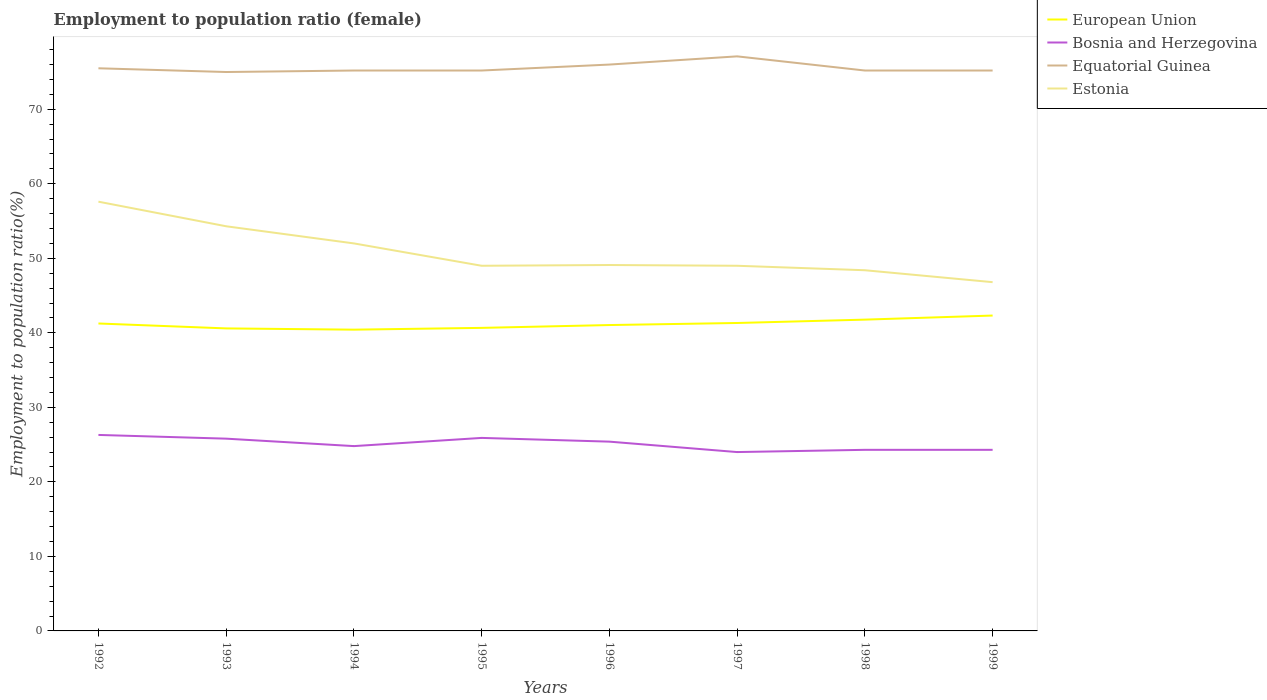Is the number of lines equal to the number of legend labels?
Offer a very short reply. Yes. What is the total employment to population ratio in Estonia in the graph?
Provide a short and direct response. 0.6. What is the difference between the highest and the second highest employment to population ratio in Bosnia and Herzegovina?
Your answer should be compact. 2.3. What is the difference between the highest and the lowest employment to population ratio in Equatorial Guinea?
Offer a very short reply. 2. Is the employment to population ratio in European Union strictly greater than the employment to population ratio in Estonia over the years?
Your answer should be very brief. Yes. How many years are there in the graph?
Your answer should be compact. 8. Are the values on the major ticks of Y-axis written in scientific E-notation?
Ensure brevity in your answer.  No. Does the graph contain grids?
Your answer should be very brief. No. What is the title of the graph?
Your answer should be compact. Employment to population ratio (female). Does "West Bank and Gaza" appear as one of the legend labels in the graph?
Ensure brevity in your answer.  No. What is the Employment to population ratio(%) in European Union in 1992?
Provide a succinct answer. 41.26. What is the Employment to population ratio(%) in Bosnia and Herzegovina in 1992?
Your answer should be very brief. 26.3. What is the Employment to population ratio(%) in Equatorial Guinea in 1992?
Make the answer very short. 75.5. What is the Employment to population ratio(%) of Estonia in 1992?
Offer a terse response. 57.6. What is the Employment to population ratio(%) in European Union in 1993?
Ensure brevity in your answer.  40.59. What is the Employment to population ratio(%) of Bosnia and Herzegovina in 1993?
Provide a short and direct response. 25.8. What is the Employment to population ratio(%) of Equatorial Guinea in 1993?
Give a very brief answer. 75. What is the Employment to population ratio(%) in Estonia in 1993?
Keep it short and to the point. 54.3. What is the Employment to population ratio(%) in European Union in 1994?
Your answer should be very brief. 40.43. What is the Employment to population ratio(%) of Bosnia and Herzegovina in 1994?
Provide a short and direct response. 24.8. What is the Employment to population ratio(%) of Equatorial Guinea in 1994?
Ensure brevity in your answer.  75.2. What is the Employment to population ratio(%) in Estonia in 1994?
Keep it short and to the point. 52. What is the Employment to population ratio(%) in European Union in 1995?
Your answer should be very brief. 40.67. What is the Employment to population ratio(%) of Bosnia and Herzegovina in 1995?
Your answer should be very brief. 25.9. What is the Employment to population ratio(%) of Equatorial Guinea in 1995?
Make the answer very short. 75.2. What is the Employment to population ratio(%) in European Union in 1996?
Ensure brevity in your answer.  41.05. What is the Employment to population ratio(%) in Bosnia and Herzegovina in 1996?
Provide a short and direct response. 25.4. What is the Employment to population ratio(%) of Equatorial Guinea in 1996?
Ensure brevity in your answer.  76. What is the Employment to population ratio(%) of Estonia in 1996?
Your response must be concise. 49.1. What is the Employment to population ratio(%) of European Union in 1997?
Provide a succinct answer. 41.32. What is the Employment to population ratio(%) of Equatorial Guinea in 1997?
Offer a very short reply. 77.1. What is the Employment to population ratio(%) of Estonia in 1997?
Provide a short and direct response. 49. What is the Employment to population ratio(%) of European Union in 1998?
Your response must be concise. 41.77. What is the Employment to population ratio(%) in Bosnia and Herzegovina in 1998?
Your answer should be very brief. 24.3. What is the Employment to population ratio(%) in Equatorial Guinea in 1998?
Ensure brevity in your answer.  75.2. What is the Employment to population ratio(%) in Estonia in 1998?
Give a very brief answer. 48.4. What is the Employment to population ratio(%) of European Union in 1999?
Give a very brief answer. 42.32. What is the Employment to population ratio(%) of Bosnia and Herzegovina in 1999?
Make the answer very short. 24.3. What is the Employment to population ratio(%) in Equatorial Guinea in 1999?
Keep it short and to the point. 75.2. What is the Employment to population ratio(%) in Estonia in 1999?
Ensure brevity in your answer.  46.8. Across all years, what is the maximum Employment to population ratio(%) in European Union?
Keep it short and to the point. 42.32. Across all years, what is the maximum Employment to population ratio(%) in Bosnia and Herzegovina?
Provide a succinct answer. 26.3. Across all years, what is the maximum Employment to population ratio(%) in Equatorial Guinea?
Offer a terse response. 77.1. Across all years, what is the maximum Employment to population ratio(%) in Estonia?
Offer a very short reply. 57.6. Across all years, what is the minimum Employment to population ratio(%) in European Union?
Provide a succinct answer. 40.43. Across all years, what is the minimum Employment to population ratio(%) of Bosnia and Herzegovina?
Offer a terse response. 24. Across all years, what is the minimum Employment to population ratio(%) in Equatorial Guinea?
Provide a succinct answer. 75. Across all years, what is the minimum Employment to population ratio(%) of Estonia?
Provide a succinct answer. 46.8. What is the total Employment to population ratio(%) in European Union in the graph?
Ensure brevity in your answer.  329.4. What is the total Employment to population ratio(%) of Bosnia and Herzegovina in the graph?
Your answer should be compact. 200.8. What is the total Employment to population ratio(%) of Equatorial Guinea in the graph?
Your response must be concise. 604.4. What is the total Employment to population ratio(%) of Estonia in the graph?
Keep it short and to the point. 406.2. What is the difference between the Employment to population ratio(%) of European Union in 1992 and that in 1993?
Offer a very short reply. 0.66. What is the difference between the Employment to population ratio(%) of Equatorial Guinea in 1992 and that in 1993?
Offer a terse response. 0.5. What is the difference between the Employment to population ratio(%) in Estonia in 1992 and that in 1993?
Provide a short and direct response. 3.3. What is the difference between the Employment to population ratio(%) in European Union in 1992 and that in 1994?
Offer a very short reply. 0.83. What is the difference between the Employment to population ratio(%) in European Union in 1992 and that in 1995?
Your response must be concise. 0.59. What is the difference between the Employment to population ratio(%) in Bosnia and Herzegovina in 1992 and that in 1995?
Your answer should be very brief. 0.4. What is the difference between the Employment to population ratio(%) in Estonia in 1992 and that in 1995?
Offer a very short reply. 8.6. What is the difference between the Employment to population ratio(%) of European Union in 1992 and that in 1996?
Offer a very short reply. 0.21. What is the difference between the Employment to population ratio(%) in Equatorial Guinea in 1992 and that in 1996?
Your answer should be very brief. -0.5. What is the difference between the Employment to population ratio(%) of European Union in 1992 and that in 1997?
Offer a very short reply. -0.07. What is the difference between the Employment to population ratio(%) of European Union in 1992 and that in 1998?
Keep it short and to the point. -0.52. What is the difference between the Employment to population ratio(%) of Estonia in 1992 and that in 1998?
Give a very brief answer. 9.2. What is the difference between the Employment to population ratio(%) in European Union in 1992 and that in 1999?
Make the answer very short. -1.06. What is the difference between the Employment to population ratio(%) in Equatorial Guinea in 1992 and that in 1999?
Ensure brevity in your answer.  0.3. What is the difference between the Employment to population ratio(%) of Estonia in 1992 and that in 1999?
Keep it short and to the point. 10.8. What is the difference between the Employment to population ratio(%) of European Union in 1993 and that in 1994?
Your answer should be compact. 0.17. What is the difference between the Employment to population ratio(%) of Bosnia and Herzegovina in 1993 and that in 1994?
Ensure brevity in your answer.  1. What is the difference between the Employment to population ratio(%) in Estonia in 1993 and that in 1994?
Your answer should be very brief. 2.3. What is the difference between the Employment to population ratio(%) of European Union in 1993 and that in 1995?
Your answer should be very brief. -0.07. What is the difference between the Employment to population ratio(%) in Bosnia and Herzegovina in 1993 and that in 1995?
Your answer should be compact. -0.1. What is the difference between the Employment to population ratio(%) in Equatorial Guinea in 1993 and that in 1995?
Offer a terse response. -0.2. What is the difference between the Employment to population ratio(%) of Estonia in 1993 and that in 1995?
Your answer should be compact. 5.3. What is the difference between the Employment to population ratio(%) of European Union in 1993 and that in 1996?
Provide a succinct answer. -0.45. What is the difference between the Employment to population ratio(%) of Bosnia and Herzegovina in 1993 and that in 1996?
Ensure brevity in your answer.  0.4. What is the difference between the Employment to population ratio(%) of European Union in 1993 and that in 1997?
Your answer should be compact. -0.73. What is the difference between the Employment to population ratio(%) in Estonia in 1993 and that in 1997?
Your answer should be compact. 5.3. What is the difference between the Employment to population ratio(%) in European Union in 1993 and that in 1998?
Your answer should be compact. -1.18. What is the difference between the Employment to population ratio(%) of Bosnia and Herzegovina in 1993 and that in 1998?
Provide a succinct answer. 1.5. What is the difference between the Employment to population ratio(%) in Equatorial Guinea in 1993 and that in 1998?
Keep it short and to the point. -0.2. What is the difference between the Employment to population ratio(%) of Estonia in 1993 and that in 1998?
Provide a short and direct response. 5.9. What is the difference between the Employment to population ratio(%) of European Union in 1993 and that in 1999?
Provide a succinct answer. -1.73. What is the difference between the Employment to population ratio(%) in Estonia in 1993 and that in 1999?
Offer a terse response. 7.5. What is the difference between the Employment to population ratio(%) of European Union in 1994 and that in 1995?
Make the answer very short. -0.24. What is the difference between the Employment to population ratio(%) in Bosnia and Herzegovina in 1994 and that in 1995?
Give a very brief answer. -1.1. What is the difference between the Employment to population ratio(%) of Equatorial Guinea in 1994 and that in 1995?
Your answer should be compact. 0. What is the difference between the Employment to population ratio(%) in European Union in 1994 and that in 1996?
Your answer should be compact. -0.62. What is the difference between the Employment to population ratio(%) of European Union in 1994 and that in 1997?
Your answer should be compact. -0.89. What is the difference between the Employment to population ratio(%) of Equatorial Guinea in 1994 and that in 1997?
Make the answer very short. -1.9. What is the difference between the Employment to population ratio(%) of European Union in 1994 and that in 1998?
Offer a terse response. -1.35. What is the difference between the Employment to population ratio(%) of European Union in 1994 and that in 1999?
Ensure brevity in your answer.  -1.89. What is the difference between the Employment to population ratio(%) in Bosnia and Herzegovina in 1994 and that in 1999?
Make the answer very short. 0.5. What is the difference between the Employment to population ratio(%) in Estonia in 1994 and that in 1999?
Give a very brief answer. 5.2. What is the difference between the Employment to population ratio(%) in European Union in 1995 and that in 1996?
Provide a succinct answer. -0.38. What is the difference between the Employment to population ratio(%) in Equatorial Guinea in 1995 and that in 1996?
Offer a very short reply. -0.8. What is the difference between the Employment to population ratio(%) in Estonia in 1995 and that in 1996?
Your answer should be compact. -0.1. What is the difference between the Employment to population ratio(%) of European Union in 1995 and that in 1997?
Keep it short and to the point. -0.65. What is the difference between the Employment to population ratio(%) in Equatorial Guinea in 1995 and that in 1997?
Your answer should be very brief. -1.9. What is the difference between the Employment to population ratio(%) in European Union in 1995 and that in 1998?
Offer a very short reply. -1.11. What is the difference between the Employment to population ratio(%) in Bosnia and Herzegovina in 1995 and that in 1998?
Your response must be concise. 1.6. What is the difference between the Employment to population ratio(%) of Estonia in 1995 and that in 1998?
Your answer should be very brief. 0.6. What is the difference between the Employment to population ratio(%) of European Union in 1995 and that in 1999?
Your response must be concise. -1.65. What is the difference between the Employment to population ratio(%) in Bosnia and Herzegovina in 1995 and that in 1999?
Ensure brevity in your answer.  1.6. What is the difference between the Employment to population ratio(%) of Equatorial Guinea in 1995 and that in 1999?
Your answer should be very brief. 0. What is the difference between the Employment to population ratio(%) of Estonia in 1995 and that in 1999?
Ensure brevity in your answer.  2.2. What is the difference between the Employment to population ratio(%) in European Union in 1996 and that in 1997?
Your answer should be very brief. -0.28. What is the difference between the Employment to population ratio(%) of European Union in 1996 and that in 1998?
Offer a terse response. -0.73. What is the difference between the Employment to population ratio(%) in Equatorial Guinea in 1996 and that in 1998?
Make the answer very short. 0.8. What is the difference between the Employment to population ratio(%) in European Union in 1996 and that in 1999?
Make the answer very short. -1.27. What is the difference between the Employment to population ratio(%) of Bosnia and Herzegovina in 1996 and that in 1999?
Your answer should be very brief. 1.1. What is the difference between the Employment to population ratio(%) of Equatorial Guinea in 1996 and that in 1999?
Keep it short and to the point. 0.8. What is the difference between the Employment to population ratio(%) in Estonia in 1996 and that in 1999?
Ensure brevity in your answer.  2.3. What is the difference between the Employment to population ratio(%) of European Union in 1997 and that in 1998?
Make the answer very short. -0.45. What is the difference between the Employment to population ratio(%) in European Union in 1997 and that in 1999?
Give a very brief answer. -1. What is the difference between the Employment to population ratio(%) in Estonia in 1997 and that in 1999?
Offer a very short reply. 2.2. What is the difference between the Employment to population ratio(%) of European Union in 1998 and that in 1999?
Offer a terse response. -0.55. What is the difference between the Employment to population ratio(%) of European Union in 1992 and the Employment to population ratio(%) of Bosnia and Herzegovina in 1993?
Your answer should be very brief. 15.46. What is the difference between the Employment to population ratio(%) of European Union in 1992 and the Employment to population ratio(%) of Equatorial Guinea in 1993?
Your answer should be compact. -33.74. What is the difference between the Employment to population ratio(%) of European Union in 1992 and the Employment to population ratio(%) of Estonia in 1993?
Your response must be concise. -13.04. What is the difference between the Employment to population ratio(%) in Bosnia and Herzegovina in 1992 and the Employment to population ratio(%) in Equatorial Guinea in 1993?
Keep it short and to the point. -48.7. What is the difference between the Employment to population ratio(%) of Bosnia and Herzegovina in 1992 and the Employment to population ratio(%) of Estonia in 1993?
Your answer should be very brief. -28. What is the difference between the Employment to population ratio(%) in Equatorial Guinea in 1992 and the Employment to population ratio(%) in Estonia in 1993?
Make the answer very short. 21.2. What is the difference between the Employment to population ratio(%) in European Union in 1992 and the Employment to population ratio(%) in Bosnia and Herzegovina in 1994?
Keep it short and to the point. 16.45. What is the difference between the Employment to population ratio(%) of European Union in 1992 and the Employment to population ratio(%) of Equatorial Guinea in 1994?
Your response must be concise. -33.95. What is the difference between the Employment to population ratio(%) of European Union in 1992 and the Employment to population ratio(%) of Estonia in 1994?
Your response must be concise. -10.74. What is the difference between the Employment to population ratio(%) of Bosnia and Herzegovina in 1992 and the Employment to population ratio(%) of Equatorial Guinea in 1994?
Your answer should be compact. -48.9. What is the difference between the Employment to population ratio(%) of Bosnia and Herzegovina in 1992 and the Employment to population ratio(%) of Estonia in 1994?
Offer a terse response. -25.7. What is the difference between the Employment to population ratio(%) in Equatorial Guinea in 1992 and the Employment to population ratio(%) in Estonia in 1994?
Ensure brevity in your answer.  23.5. What is the difference between the Employment to population ratio(%) of European Union in 1992 and the Employment to population ratio(%) of Bosnia and Herzegovina in 1995?
Offer a terse response. 15.36. What is the difference between the Employment to population ratio(%) in European Union in 1992 and the Employment to population ratio(%) in Equatorial Guinea in 1995?
Offer a terse response. -33.95. What is the difference between the Employment to population ratio(%) in European Union in 1992 and the Employment to population ratio(%) in Estonia in 1995?
Your response must be concise. -7.75. What is the difference between the Employment to population ratio(%) in Bosnia and Herzegovina in 1992 and the Employment to population ratio(%) in Equatorial Guinea in 1995?
Make the answer very short. -48.9. What is the difference between the Employment to population ratio(%) of Bosnia and Herzegovina in 1992 and the Employment to population ratio(%) of Estonia in 1995?
Provide a succinct answer. -22.7. What is the difference between the Employment to population ratio(%) of Equatorial Guinea in 1992 and the Employment to population ratio(%) of Estonia in 1995?
Keep it short and to the point. 26.5. What is the difference between the Employment to population ratio(%) of European Union in 1992 and the Employment to population ratio(%) of Bosnia and Herzegovina in 1996?
Your response must be concise. 15.86. What is the difference between the Employment to population ratio(%) of European Union in 1992 and the Employment to population ratio(%) of Equatorial Guinea in 1996?
Give a very brief answer. -34.74. What is the difference between the Employment to population ratio(%) in European Union in 1992 and the Employment to population ratio(%) in Estonia in 1996?
Make the answer very short. -7.84. What is the difference between the Employment to population ratio(%) of Bosnia and Herzegovina in 1992 and the Employment to population ratio(%) of Equatorial Guinea in 1996?
Ensure brevity in your answer.  -49.7. What is the difference between the Employment to population ratio(%) of Bosnia and Herzegovina in 1992 and the Employment to population ratio(%) of Estonia in 1996?
Your response must be concise. -22.8. What is the difference between the Employment to population ratio(%) in Equatorial Guinea in 1992 and the Employment to population ratio(%) in Estonia in 1996?
Your answer should be compact. 26.4. What is the difference between the Employment to population ratio(%) of European Union in 1992 and the Employment to population ratio(%) of Bosnia and Herzegovina in 1997?
Offer a terse response. 17.25. What is the difference between the Employment to population ratio(%) of European Union in 1992 and the Employment to population ratio(%) of Equatorial Guinea in 1997?
Make the answer very short. -35.84. What is the difference between the Employment to population ratio(%) of European Union in 1992 and the Employment to population ratio(%) of Estonia in 1997?
Your answer should be very brief. -7.75. What is the difference between the Employment to population ratio(%) in Bosnia and Herzegovina in 1992 and the Employment to population ratio(%) in Equatorial Guinea in 1997?
Your answer should be compact. -50.8. What is the difference between the Employment to population ratio(%) of Bosnia and Herzegovina in 1992 and the Employment to population ratio(%) of Estonia in 1997?
Keep it short and to the point. -22.7. What is the difference between the Employment to population ratio(%) of European Union in 1992 and the Employment to population ratio(%) of Bosnia and Herzegovina in 1998?
Your response must be concise. 16.95. What is the difference between the Employment to population ratio(%) of European Union in 1992 and the Employment to population ratio(%) of Equatorial Guinea in 1998?
Keep it short and to the point. -33.95. What is the difference between the Employment to population ratio(%) in European Union in 1992 and the Employment to population ratio(%) in Estonia in 1998?
Keep it short and to the point. -7.14. What is the difference between the Employment to population ratio(%) of Bosnia and Herzegovina in 1992 and the Employment to population ratio(%) of Equatorial Guinea in 1998?
Provide a succinct answer. -48.9. What is the difference between the Employment to population ratio(%) in Bosnia and Herzegovina in 1992 and the Employment to population ratio(%) in Estonia in 1998?
Your answer should be very brief. -22.1. What is the difference between the Employment to population ratio(%) in Equatorial Guinea in 1992 and the Employment to population ratio(%) in Estonia in 1998?
Provide a short and direct response. 27.1. What is the difference between the Employment to population ratio(%) in European Union in 1992 and the Employment to population ratio(%) in Bosnia and Herzegovina in 1999?
Provide a short and direct response. 16.95. What is the difference between the Employment to population ratio(%) in European Union in 1992 and the Employment to population ratio(%) in Equatorial Guinea in 1999?
Offer a terse response. -33.95. What is the difference between the Employment to population ratio(%) in European Union in 1992 and the Employment to population ratio(%) in Estonia in 1999?
Offer a terse response. -5.54. What is the difference between the Employment to population ratio(%) of Bosnia and Herzegovina in 1992 and the Employment to population ratio(%) of Equatorial Guinea in 1999?
Ensure brevity in your answer.  -48.9. What is the difference between the Employment to population ratio(%) in Bosnia and Herzegovina in 1992 and the Employment to population ratio(%) in Estonia in 1999?
Offer a very short reply. -20.5. What is the difference between the Employment to population ratio(%) in Equatorial Guinea in 1992 and the Employment to population ratio(%) in Estonia in 1999?
Keep it short and to the point. 28.7. What is the difference between the Employment to population ratio(%) of European Union in 1993 and the Employment to population ratio(%) of Bosnia and Herzegovina in 1994?
Give a very brief answer. 15.79. What is the difference between the Employment to population ratio(%) of European Union in 1993 and the Employment to population ratio(%) of Equatorial Guinea in 1994?
Give a very brief answer. -34.61. What is the difference between the Employment to population ratio(%) of European Union in 1993 and the Employment to population ratio(%) of Estonia in 1994?
Your answer should be very brief. -11.41. What is the difference between the Employment to population ratio(%) in Bosnia and Herzegovina in 1993 and the Employment to population ratio(%) in Equatorial Guinea in 1994?
Give a very brief answer. -49.4. What is the difference between the Employment to population ratio(%) in Bosnia and Herzegovina in 1993 and the Employment to population ratio(%) in Estonia in 1994?
Offer a very short reply. -26.2. What is the difference between the Employment to population ratio(%) of European Union in 1993 and the Employment to population ratio(%) of Bosnia and Herzegovina in 1995?
Offer a very short reply. 14.69. What is the difference between the Employment to population ratio(%) in European Union in 1993 and the Employment to population ratio(%) in Equatorial Guinea in 1995?
Offer a very short reply. -34.61. What is the difference between the Employment to population ratio(%) of European Union in 1993 and the Employment to population ratio(%) of Estonia in 1995?
Your response must be concise. -8.41. What is the difference between the Employment to population ratio(%) in Bosnia and Herzegovina in 1993 and the Employment to population ratio(%) in Equatorial Guinea in 1995?
Offer a terse response. -49.4. What is the difference between the Employment to population ratio(%) in Bosnia and Herzegovina in 1993 and the Employment to population ratio(%) in Estonia in 1995?
Your answer should be very brief. -23.2. What is the difference between the Employment to population ratio(%) in European Union in 1993 and the Employment to population ratio(%) in Bosnia and Herzegovina in 1996?
Provide a short and direct response. 15.19. What is the difference between the Employment to population ratio(%) in European Union in 1993 and the Employment to population ratio(%) in Equatorial Guinea in 1996?
Give a very brief answer. -35.41. What is the difference between the Employment to population ratio(%) of European Union in 1993 and the Employment to population ratio(%) of Estonia in 1996?
Provide a short and direct response. -8.51. What is the difference between the Employment to population ratio(%) of Bosnia and Herzegovina in 1993 and the Employment to population ratio(%) of Equatorial Guinea in 1996?
Your answer should be very brief. -50.2. What is the difference between the Employment to population ratio(%) in Bosnia and Herzegovina in 1993 and the Employment to population ratio(%) in Estonia in 1996?
Provide a succinct answer. -23.3. What is the difference between the Employment to population ratio(%) of Equatorial Guinea in 1993 and the Employment to population ratio(%) of Estonia in 1996?
Provide a short and direct response. 25.9. What is the difference between the Employment to population ratio(%) in European Union in 1993 and the Employment to population ratio(%) in Bosnia and Herzegovina in 1997?
Give a very brief answer. 16.59. What is the difference between the Employment to population ratio(%) of European Union in 1993 and the Employment to population ratio(%) of Equatorial Guinea in 1997?
Your answer should be very brief. -36.51. What is the difference between the Employment to population ratio(%) of European Union in 1993 and the Employment to population ratio(%) of Estonia in 1997?
Keep it short and to the point. -8.41. What is the difference between the Employment to population ratio(%) of Bosnia and Herzegovina in 1993 and the Employment to population ratio(%) of Equatorial Guinea in 1997?
Make the answer very short. -51.3. What is the difference between the Employment to population ratio(%) of Bosnia and Herzegovina in 1993 and the Employment to population ratio(%) of Estonia in 1997?
Your response must be concise. -23.2. What is the difference between the Employment to population ratio(%) in European Union in 1993 and the Employment to population ratio(%) in Bosnia and Herzegovina in 1998?
Offer a very short reply. 16.29. What is the difference between the Employment to population ratio(%) in European Union in 1993 and the Employment to population ratio(%) in Equatorial Guinea in 1998?
Offer a very short reply. -34.61. What is the difference between the Employment to population ratio(%) in European Union in 1993 and the Employment to population ratio(%) in Estonia in 1998?
Your response must be concise. -7.81. What is the difference between the Employment to population ratio(%) in Bosnia and Herzegovina in 1993 and the Employment to population ratio(%) in Equatorial Guinea in 1998?
Offer a terse response. -49.4. What is the difference between the Employment to population ratio(%) in Bosnia and Herzegovina in 1993 and the Employment to population ratio(%) in Estonia in 1998?
Your response must be concise. -22.6. What is the difference between the Employment to population ratio(%) in Equatorial Guinea in 1993 and the Employment to population ratio(%) in Estonia in 1998?
Your answer should be very brief. 26.6. What is the difference between the Employment to population ratio(%) in European Union in 1993 and the Employment to population ratio(%) in Bosnia and Herzegovina in 1999?
Your response must be concise. 16.29. What is the difference between the Employment to population ratio(%) in European Union in 1993 and the Employment to population ratio(%) in Equatorial Guinea in 1999?
Your response must be concise. -34.61. What is the difference between the Employment to population ratio(%) in European Union in 1993 and the Employment to population ratio(%) in Estonia in 1999?
Give a very brief answer. -6.21. What is the difference between the Employment to population ratio(%) of Bosnia and Herzegovina in 1993 and the Employment to population ratio(%) of Equatorial Guinea in 1999?
Offer a terse response. -49.4. What is the difference between the Employment to population ratio(%) in Bosnia and Herzegovina in 1993 and the Employment to population ratio(%) in Estonia in 1999?
Offer a very short reply. -21. What is the difference between the Employment to population ratio(%) in Equatorial Guinea in 1993 and the Employment to population ratio(%) in Estonia in 1999?
Provide a succinct answer. 28.2. What is the difference between the Employment to population ratio(%) in European Union in 1994 and the Employment to population ratio(%) in Bosnia and Herzegovina in 1995?
Give a very brief answer. 14.53. What is the difference between the Employment to population ratio(%) of European Union in 1994 and the Employment to population ratio(%) of Equatorial Guinea in 1995?
Provide a short and direct response. -34.77. What is the difference between the Employment to population ratio(%) in European Union in 1994 and the Employment to population ratio(%) in Estonia in 1995?
Your response must be concise. -8.57. What is the difference between the Employment to population ratio(%) of Bosnia and Herzegovina in 1994 and the Employment to population ratio(%) of Equatorial Guinea in 1995?
Your answer should be very brief. -50.4. What is the difference between the Employment to population ratio(%) in Bosnia and Herzegovina in 1994 and the Employment to population ratio(%) in Estonia in 1995?
Your response must be concise. -24.2. What is the difference between the Employment to population ratio(%) in Equatorial Guinea in 1994 and the Employment to population ratio(%) in Estonia in 1995?
Your response must be concise. 26.2. What is the difference between the Employment to population ratio(%) in European Union in 1994 and the Employment to population ratio(%) in Bosnia and Herzegovina in 1996?
Make the answer very short. 15.03. What is the difference between the Employment to population ratio(%) of European Union in 1994 and the Employment to population ratio(%) of Equatorial Guinea in 1996?
Ensure brevity in your answer.  -35.57. What is the difference between the Employment to population ratio(%) of European Union in 1994 and the Employment to population ratio(%) of Estonia in 1996?
Provide a short and direct response. -8.67. What is the difference between the Employment to population ratio(%) in Bosnia and Herzegovina in 1994 and the Employment to population ratio(%) in Equatorial Guinea in 1996?
Keep it short and to the point. -51.2. What is the difference between the Employment to population ratio(%) in Bosnia and Herzegovina in 1994 and the Employment to population ratio(%) in Estonia in 1996?
Provide a succinct answer. -24.3. What is the difference between the Employment to population ratio(%) of Equatorial Guinea in 1994 and the Employment to population ratio(%) of Estonia in 1996?
Your answer should be very brief. 26.1. What is the difference between the Employment to population ratio(%) of European Union in 1994 and the Employment to population ratio(%) of Bosnia and Herzegovina in 1997?
Your response must be concise. 16.43. What is the difference between the Employment to population ratio(%) of European Union in 1994 and the Employment to population ratio(%) of Equatorial Guinea in 1997?
Give a very brief answer. -36.67. What is the difference between the Employment to population ratio(%) of European Union in 1994 and the Employment to population ratio(%) of Estonia in 1997?
Provide a succinct answer. -8.57. What is the difference between the Employment to population ratio(%) of Bosnia and Herzegovina in 1994 and the Employment to population ratio(%) of Equatorial Guinea in 1997?
Your answer should be very brief. -52.3. What is the difference between the Employment to population ratio(%) of Bosnia and Herzegovina in 1994 and the Employment to population ratio(%) of Estonia in 1997?
Offer a terse response. -24.2. What is the difference between the Employment to population ratio(%) of Equatorial Guinea in 1994 and the Employment to population ratio(%) of Estonia in 1997?
Provide a short and direct response. 26.2. What is the difference between the Employment to population ratio(%) of European Union in 1994 and the Employment to population ratio(%) of Bosnia and Herzegovina in 1998?
Keep it short and to the point. 16.13. What is the difference between the Employment to population ratio(%) in European Union in 1994 and the Employment to population ratio(%) in Equatorial Guinea in 1998?
Ensure brevity in your answer.  -34.77. What is the difference between the Employment to population ratio(%) of European Union in 1994 and the Employment to population ratio(%) of Estonia in 1998?
Provide a succinct answer. -7.97. What is the difference between the Employment to population ratio(%) in Bosnia and Herzegovina in 1994 and the Employment to population ratio(%) in Equatorial Guinea in 1998?
Your response must be concise. -50.4. What is the difference between the Employment to population ratio(%) in Bosnia and Herzegovina in 1994 and the Employment to population ratio(%) in Estonia in 1998?
Your answer should be very brief. -23.6. What is the difference between the Employment to population ratio(%) in Equatorial Guinea in 1994 and the Employment to population ratio(%) in Estonia in 1998?
Provide a succinct answer. 26.8. What is the difference between the Employment to population ratio(%) of European Union in 1994 and the Employment to population ratio(%) of Bosnia and Herzegovina in 1999?
Provide a short and direct response. 16.13. What is the difference between the Employment to population ratio(%) in European Union in 1994 and the Employment to population ratio(%) in Equatorial Guinea in 1999?
Your response must be concise. -34.77. What is the difference between the Employment to population ratio(%) of European Union in 1994 and the Employment to population ratio(%) of Estonia in 1999?
Your answer should be very brief. -6.37. What is the difference between the Employment to population ratio(%) in Bosnia and Herzegovina in 1994 and the Employment to population ratio(%) in Equatorial Guinea in 1999?
Keep it short and to the point. -50.4. What is the difference between the Employment to population ratio(%) of Bosnia and Herzegovina in 1994 and the Employment to population ratio(%) of Estonia in 1999?
Provide a succinct answer. -22. What is the difference between the Employment to population ratio(%) of Equatorial Guinea in 1994 and the Employment to population ratio(%) of Estonia in 1999?
Your answer should be very brief. 28.4. What is the difference between the Employment to population ratio(%) of European Union in 1995 and the Employment to population ratio(%) of Bosnia and Herzegovina in 1996?
Give a very brief answer. 15.27. What is the difference between the Employment to population ratio(%) of European Union in 1995 and the Employment to population ratio(%) of Equatorial Guinea in 1996?
Offer a terse response. -35.33. What is the difference between the Employment to population ratio(%) in European Union in 1995 and the Employment to population ratio(%) in Estonia in 1996?
Give a very brief answer. -8.43. What is the difference between the Employment to population ratio(%) of Bosnia and Herzegovina in 1995 and the Employment to population ratio(%) of Equatorial Guinea in 1996?
Your answer should be very brief. -50.1. What is the difference between the Employment to population ratio(%) in Bosnia and Herzegovina in 1995 and the Employment to population ratio(%) in Estonia in 1996?
Offer a terse response. -23.2. What is the difference between the Employment to population ratio(%) of Equatorial Guinea in 1995 and the Employment to population ratio(%) of Estonia in 1996?
Provide a succinct answer. 26.1. What is the difference between the Employment to population ratio(%) in European Union in 1995 and the Employment to population ratio(%) in Bosnia and Herzegovina in 1997?
Your answer should be compact. 16.67. What is the difference between the Employment to population ratio(%) in European Union in 1995 and the Employment to population ratio(%) in Equatorial Guinea in 1997?
Offer a terse response. -36.43. What is the difference between the Employment to population ratio(%) of European Union in 1995 and the Employment to population ratio(%) of Estonia in 1997?
Keep it short and to the point. -8.33. What is the difference between the Employment to population ratio(%) in Bosnia and Herzegovina in 1995 and the Employment to population ratio(%) in Equatorial Guinea in 1997?
Provide a succinct answer. -51.2. What is the difference between the Employment to population ratio(%) in Bosnia and Herzegovina in 1995 and the Employment to population ratio(%) in Estonia in 1997?
Provide a succinct answer. -23.1. What is the difference between the Employment to population ratio(%) in Equatorial Guinea in 1995 and the Employment to population ratio(%) in Estonia in 1997?
Ensure brevity in your answer.  26.2. What is the difference between the Employment to population ratio(%) in European Union in 1995 and the Employment to population ratio(%) in Bosnia and Herzegovina in 1998?
Offer a very short reply. 16.37. What is the difference between the Employment to population ratio(%) in European Union in 1995 and the Employment to population ratio(%) in Equatorial Guinea in 1998?
Offer a terse response. -34.53. What is the difference between the Employment to population ratio(%) of European Union in 1995 and the Employment to population ratio(%) of Estonia in 1998?
Your answer should be very brief. -7.73. What is the difference between the Employment to population ratio(%) in Bosnia and Herzegovina in 1995 and the Employment to population ratio(%) in Equatorial Guinea in 1998?
Offer a very short reply. -49.3. What is the difference between the Employment to population ratio(%) in Bosnia and Herzegovina in 1995 and the Employment to population ratio(%) in Estonia in 1998?
Make the answer very short. -22.5. What is the difference between the Employment to population ratio(%) of Equatorial Guinea in 1995 and the Employment to population ratio(%) of Estonia in 1998?
Your answer should be compact. 26.8. What is the difference between the Employment to population ratio(%) of European Union in 1995 and the Employment to population ratio(%) of Bosnia and Herzegovina in 1999?
Offer a terse response. 16.37. What is the difference between the Employment to population ratio(%) of European Union in 1995 and the Employment to population ratio(%) of Equatorial Guinea in 1999?
Keep it short and to the point. -34.53. What is the difference between the Employment to population ratio(%) in European Union in 1995 and the Employment to population ratio(%) in Estonia in 1999?
Give a very brief answer. -6.13. What is the difference between the Employment to population ratio(%) in Bosnia and Herzegovina in 1995 and the Employment to population ratio(%) in Equatorial Guinea in 1999?
Your response must be concise. -49.3. What is the difference between the Employment to population ratio(%) in Bosnia and Herzegovina in 1995 and the Employment to population ratio(%) in Estonia in 1999?
Keep it short and to the point. -20.9. What is the difference between the Employment to population ratio(%) of Equatorial Guinea in 1995 and the Employment to population ratio(%) of Estonia in 1999?
Your answer should be very brief. 28.4. What is the difference between the Employment to population ratio(%) in European Union in 1996 and the Employment to population ratio(%) in Bosnia and Herzegovina in 1997?
Ensure brevity in your answer.  17.05. What is the difference between the Employment to population ratio(%) in European Union in 1996 and the Employment to population ratio(%) in Equatorial Guinea in 1997?
Offer a very short reply. -36.05. What is the difference between the Employment to population ratio(%) of European Union in 1996 and the Employment to population ratio(%) of Estonia in 1997?
Offer a very short reply. -7.95. What is the difference between the Employment to population ratio(%) in Bosnia and Herzegovina in 1996 and the Employment to population ratio(%) in Equatorial Guinea in 1997?
Your answer should be compact. -51.7. What is the difference between the Employment to population ratio(%) in Bosnia and Herzegovina in 1996 and the Employment to population ratio(%) in Estonia in 1997?
Your answer should be very brief. -23.6. What is the difference between the Employment to population ratio(%) of Equatorial Guinea in 1996 and the Employment to population ratio(%) of Estonia in 1997?
Offer a very short reply. 27. What is the difference between the Employment to population ratio(%) of European Union in 1996 and the Employment to population ratio(%) of Bosnia and Herzegovina in 1998?
Your response must be concise. 16.75. What is the difference between the Employment to population ratio(%) in European Union in 1996 and the Employment to population ratio(%) in Equatorial Guinea in 1998?
Make the answer very short. -34.15. What is the difference between the Employment to population ratio(%) of European Union in 1996 and the Employment to population ratio(%) of Estonia in 1998?
Your answer should be compact. -7.35. What is the difference between the Employment to population ratio(%) in Bosnia and Herzegovina in 1996 and the Employment to population ratio(%) in Equatorial Guinea in 1998?
Make the answer very short. -49.8. What is the difference between the Employment to population ratio(%) of Bosnia and Herzegovina in 1996 and the Employment to population ratio(%) of Estonia in 1998?
Ensure brevity in your answer.  -23. What is the difference between the Employment to population ratio(%) of Equatorial Guinea in 1996 and the Employment to population ratio(%) of Estonia in 1998?
Keep it short and to the point. 27.6. What is the difference between the Employment to population ratio(%) of European Union in 1996 and the Employment to population ratio(%) of Bosnia and Herzegovina in 1999?
Your answer should be compact. 16.75. What is the difference between the Employment to population ratio(%) in European Union in 1996 and the Employment to population ratio(%) in Equatorial Guinea in 1999?
Provide a short and direct response. -34.15. What is the difference between the Employment to population ratio(%) of European Union in 1996 and the Employment to population ratio(%) of Estonia in 1999?
Give a very brief answer. -5.75. What is the difference between the Employment to population ratio(%) of Bosnia and Herzegovina in 1996 and the Employment to population ratio(%) of Equatorial Guinea in 1999?
Your response must be concise. -49.8. What is the difference between the Employment to population ratio(%) in Bosnia and Herzegovina in 1996 and the Employment to population ratio(%) in Estonia in 1999?
Offer a terse response. -21.4. What is the difference between the Employment to population ratio(%) of Equatorial Guinea in 1996 and the Employment to population ratio(%) of Estonia in 1999?
Offer a terse response. 29.2. What is the difference between the Employment to population ratio(%) in European Union in 1997 and the Employment to population ratio(%) in Bosnia and Herzegovina in 1998?
Ensure brevity in your answer.  17.02. What is the difference between the Employment to population ratio(%) in European Union in 1997 and the Employment to population ratio(%) in Equatorial Guinea in 1998?
Provide a short and direct response. -33.88. What is the difference between the Employment to population ratio(%) in European Union in 1997 and the Employment to population ratio(%) in Estonia in 1998?
Offer a terse response. -7.08. What is the difference between the Employment to population ratio(%) in Bosnia and Herzegovina in 1997 and the Employment to population ratio(%) in Equatorial Guinea in 1998?
Offer a terse response. -51.2. What is the difference between the Employment to population ratio(%) of Bosnia and Herzegovina in 1997 and the Employment to population ratio(%) of Estonia in 1998?
Provide a short and direct response. -24.4. What is the difference between the Employment to population ratio(%) in Equatorial Guinea in 1997 and the Employment to population ratio(%) in Estonia in 1998?
Offer a very short reply. 28.7. What is the difference between the Employment to population ratio(%) in European Union in 1997 and the Employment to population ratio(%) in Bosnia and Herzegovina in 1999?
Provide a succinct answer. 17.02. What is the difference between the Employment to population ratio(%) in European Union in 1997 and the Employment to population ratio(%) in Equatorial Guinea in 1999?
Ensure brevity in your answer.  -33.88. What is the difference between the Employment to population ratio(%) in European Union in 1997 and the Employment to population ratio(%) in Estonia in 1999?
Ensure brevity in your answer.  -5.48. What is the difference between the Employment to population ratio(%) of Bosnia and Herzegovina in 1997 and the Employment to population ratio(%) of Equatorial Guinea in 1999?
Your response must be concise. -51.2. What is the difference between the Employment to population ratio(%) of Bosnia and Herzegovina in 1997 and the Employment to population ratio(%) of Estonia in 1999?
Make the answer very short. -22.8. What is the difference between the Employment to population ratio(%) of Equatorial Guinea in 1997 and the Employment to population ratio(%) of Estonia in 1999?
Offer a very short reply. 30.3. What is the difference between the Employment to population ratio(%) in European Union in 1998 and the Employment to population ratio(%) in Bosnia and Herzegovina in 1999?
Your response must be concise. 17.47. What is the difference between the Employment to population ratio(%) in European Union in 1998 and the Employment to population ratio(%) in Equatorial Guinea in 1999?
Provide a succinct answer. -33.43. What is the difference between the Employment to population ratio(%) of European Union in 1998 and the Employment to population ratio(%) of Estonia in 1999?
Provide a short and direct response. -5.03. What is the difference between the Employment to population ratio(%) in Bosnia and Herzegovina in 1998 and the Employment to population ratio(%) in Equatorial Guinea in 1999?
Your answer should be very brief. -50.9. What is the difference between the Employment to population ratio(%) of Bosnia and Herzegovina in 1998 and the Employment to population ratio(%) of Estonia in 1999?
Offer a terse response. -22.5. What is the difference between the Employment to population ratio(%) in Equatorial Guinea in 1998 and the Employment to population ratio(%) in Estonia in 1999?
Provide a succinct answer. 28.4. What is the average Employment to population ratio(%) of European Union per year?
Make the answer very short. 41.17. What is the average Employment to population ratio(%) in Bosnia and Herzegovina per year?
Your response must be concise. 25.1. What is the average Employment to population ratio(%) in Equatorial Guinea per year?
Your answer should be very brief. 75.55. What is the average Employment to population ratio(%) of Estonia per year?
Your answer should be very brief. 50.77. In the year 1992, what is the difference between the Employment to population ratio(%) of European Union and Employment to population ratio(%) of Bosnia and Herzegovina?
Offer a terse response. 14.96. In the year 1992, what is the difference between the Employment to population ratio(%) in European Union and Employment to population ratio(%) in Equatorial Guinea?
Your answer should be very brief. -34.24. In the year 1992, what is the difference between the Employment to population ratio(%) of European Union and Employment to population ratio(%) of Estonia?
Ensure brevity in your answer.  -16.34. In the year 1992, what is the difference between the Employment to population ratio(%) of Bosnia and Herzegovina and Employment to population ratio(%) of Equatorial Guinea?
Your answer should be compact. -49.2. In the year 1992, what is the difference between the Employment to population ratio(%) of Bosnia and Herzegovina and Employment to population ratio(%) of Estonia?
Provide a short and direct response. -31.3. In the year 1993, what is the difference between the Employment to population ratio(%) in European Union and Employment to population ratio(%) in Bosnia and Herzegovina?
Provide a succinct answer. 14.79. In the year 1993, what is the difference between the Employment to population ratio(%) of European Union and Employment to population ratio(%) of Equatorial Guinea?
Keep it short and to the point. -34.41. In the year 1993, what is the difference between the Employment to population ratio(%) of European Union and Employment to population ratio(%) of Estonia?
Your response must be concise. -13.71. In the year 1993, what is the difference between the Employment to population ratio(%) of Bosnia and Herzegovina and Employment to population ratio(%) of Equatorial Guinea?
Provide a short and direct response. -49.2. In the year 1993, what is the difference between the Employment to population ratio(%) in Bosnia and Herzegovina and Employment to population ratio(%) in Estonia?
Provide a short and direct response. -28.5. In the year 1993, what is the difference between the Employment to population ratio(%) in Equatorial Guinea and Employment to population ratio(%) in Estonia?
Make the answer very short. 20.7. In the year 1994, what is the difference between the Employment to population ratio(%) in European Union and Employment to population ratio(%) in Bosnia and Herzegovina?
Offer a terse response. 15.63. In the year 1994, what is the difference between the Employment to population ratio(%) of European Union and Employment to population ratio(%) of Equatorial Guinea?
Offer a terse response. -34.77. In the year 1994, what is the difference between the Employment to population ratio(%) in European Union and Employment to population ratio(%) in Estonia?
Your response must be concise. -11.57. In the year 1994, what is the difference between the Employment to population ratio(%) of Bosnia and Herzegovina and Employment to population ratio(%) of Equatorial Guinea?
Provide a short and direct response. -50.4. In the year 1994, what is the difference between the Employment to population ratio(%) of Bosnia and Herzegovina and Employment to population ratio(%) of Estonia?
Your answer should be compact. -27.2. In the year 1994, what is the difference between the Employment to population ratio(%) in Equatorial Guinea and Employment to population ratio(%) in Estonia?
Your answer should be very brief. 23.2. In the year 1995, what is the difference between the Employment to population ratio(%) of European Union and Employment to population ratio(%) of Bosnia and Herzegovina?
Your answer should be compact. 14.77. In the year 1995, what is the difference between the Employment to population ratio(%) of European Union and Employment to population ratio(%) of Equatorial Guinea?
Offer a very short reply. -34.53. In the year 1995, what is the difference between the Employment to population ratio(%) in European Union and Employment to population ratio(%) in Estonia?
Make the answer very short. -8.33. In the year 1995, what is the difference between the Employment to population ratio(%) of Bosnia and Herzegovina and Employment to population ratio(%) of Equatorial Guinea?
Your answer should be compact. -49.3. In the year 1995, what is the difference between the Employment to population ratio(%) in Bosnia and Herzegovina and Employment to population ratio(%) in Estonia?
Provide a short and direct response. -23.1. In the year 1995, what is the difference between the Employment to population ratio(%) of Equatorial Guinea and Employment to population ratio(%) of Estonia?
Ensure brevity in your answer.  26.2. In the year 1996, what is the difference between the Employment to population ratio(%) in European Union and Employment to population ratio(%) in Bosnia and Herzegovina?
Ensure brevity in your answer.  15.65. In the year 1996, what is the difference between the Employment to population ratio(%) of European Union and Employment to population ratio(%) of Equatorial Guinea?
Give a very brief answer. -34.95. In the year 1996, what is the difference between the Employment to population ratio(%) of European Union and Employment to population ratio(%) of Estonia?
Keep it short and to the point. -8.05. In the year 1996, what is the difference between the Employment to population ratio(%) of Bosnia and Herzegovina and Employment to population ratio(%) of Equatorial Guinea?
Provide a short and direct response. -50.6. In the year 1996, what is the difference between the Employment to population ratio(%) of Bosnia and Herzegovina and Employment to population ratio(%) of Estonia?
Your response must be concise. -23.7. In the year 1996, what is the difference between the Employment to population ratio(%) in Equatorial Guinea and Employment to population ratio(%) in Estonia?
Ensure brevity in your answer.  26.9. In the year 1997, what is the difference between the Employment to population ratio(%) of European Union and Employment to population ratio(%) of Bosnia and Herzegovina?
Your answer should be very brief. 17.32. In the year 1997, what is the difference between the Employment to population ratio(%) in European Union and Employment to population ratio(%) in Equatorial Guinea?
Your answer should be compact. -35.78. In the year 1997, what is the difference between the Employment to population ratio(%) of European Union and Employment to population ratio(%) of Estonia?
Your answer should be very brief. -7.68. In the year 1997, what is the difference between the Employment to population ratio(%) of Bosnia and Herzegovina and Employment to population ratio(%) of Equatorial Guinea?
Give a very brief answer. -53.1. In the year 1997, what is the difference between the Employment to population ratio(%) in Bosnia and Herzegovina and Employment to population ratio(%) in Estonia?
Keep it short and to the point. -25. In the year 1997, what is the difference between the Employment to population ratio(%) of Equatorial Guinea and Employment to population ratio(%) of Estonia?
Provide a short and direct response. 28.1. In the year 1998, what is the difference between the Employment to population ratio(%) of European Union and Employment to population ratio(%) of Bosnia and Herzegovina?
Make the answer very short. 17.47. In the year 1998, what is the difference between the Employment to population ratio(%) of European Union and Employment to population ratio(%) of Equatorial Guinea?
Provide a succinct answer. -33.43. In the year 1998, what is the difference between the Employment to population ratio(%) in European Union and Employment to population ratio(%) in Estonia?
Give a very brief answer. -6.63. In the year 1998, what is the difference between the Employment to population ratio(%) of Bosnia and Herzegovina and Employment to population ratio(%) of Equatorial Guinea?
Offer a terse response. -50.9. In the year 1998, what is the difference between the Employment to population ratio(%) of Bosnia and Herzegovina and Employment to population ratio(%) of Estonia?
Your answer should be very brief. -24.1. In the year 1998, what is the difference between the Employment to population ratio(%) in Equatorial Guinea and Employment to population ratio(%) in Estonia?
Provide a short and direct response. 26.8. In the year 1999, what is the difference between the Employment to population ratio(%) of European Union and Employment to population ratio(%) of Bosnia and Herzegovina?
Offer a terse response. 18.02. In the year 1999, what is the difference between the Employment to population ratio(%) in European Union and Employment to population ratio(%) in Equatorial Guinea?
Make the answer very short. -32.88. In the year 1999, what is the difference between the Employment to population ratio(%) of European Union and Employment to population ratio(%) of Estonia?
Provide a short and direct response. -4.48. In the year 1999, what is the difference between the Employment to population ratio(%) of Bosnia and Herzegovina and Employment to population ratio(%) of Equatorial Guinea?
Give a very brief answer. -50.9. In the year 1999, what is the difference between the Employment to population ratio(%) in Bosnia and Herzegovina and Employment to population ratio(%) in Estonia?
Make the answer very short. -22.5. In the year 1999, what is the difference between the Employment to population ratio(%) in Equatorial Guinea and Employment to population ratio(%) in Estonia?
Provide a short and direct response. 28.4. What is the ratio of the Employment to population ratio(%) in European Union in 1992 to that in 1993?
Offer a terse response. 1.02. What is the ratio of the Employment to population ratio(%) of Bosnia and Herzegovina in 1992 to that in 1993?
Offer a very short reply. 1.02. What is the ratio of the Employment to population ratio(%) in Equatorial Guinea in 1992 to that in 1993?
Provide a succinct answer. 1.01. What is the ratio of the Employment to population ratio(%) of Estonia in 1992 to that in 1993?
Offer a terse response. 1.06. What is the ratio of the Employment to population ratio(%) of European Union in 1992 to that in 1994?
Provide a succinct answer. 1.02. What is the ratio of the Employment to population ratio(%) of Bosnia and Herzegovina in 1992 to that in 1994?
Your answer should be compact. 1.06. What is the ratio of the Employment to population ratio(%) of Equatorial Guinea in 1992 to that in 1994?
Your answer should be very brief. 1. What is the ratio of the Employment to population ratio(%) of Estonia in 1992 to that in 1994?
Offer a very short reply. 1.11. What is the ratio of the Employment to population ratio(%) in European Union in 1992 to that in 1995?
Provide a short and direct response. 1.01. What is the ratio of the Employment to population ratio(%) in Bosnia and Herzegovina in 1992 to that in 1995?
Provide a succinct answer. 1.02. What is the ratio of the Employment to population ratio(%) of Estonia in 1992 to that in 1995?
Your answer should be very brief. 1.18. What is the ratio of the Employment to population ratio(%) in Bosnia and Herzegovina in 1992 to that in 1996?
Your answer should be very brief. 1.04. What is the ratio of the Employment to population ratio(%) of Equatorial Guinea in 1992 to that in 1996?
Your response must be concise. 0.99. What is the ratio of the Employment to population ratio(%) of Estonia in 1992 to that in 1996?
Offer a very short reply. 1.17. What is the ratio of the Employment to population ratio(%) of Bosnia and Herzegovina in 1992 to that in 1997?
Provide a succinct answer. 1.1. What is the ratio of the Employment to population ratio(%) in Equatorial Guinea in 1992 to that in 1997?
Give a very brief answer. 0.98. What is the ratio of the Employment to population ratio(%) in Estonia in 1992 to that in 1997?
Make the answer very short. 1.18. What is the ratio of the Employment to population ratio(%) of European Union in 1992 to that in 1998?
Ensure brevity in your answer.  0.99. What is the ratio of the Employment to population ratio(%) of Bosnia and Herzegovina in 1992 to that in 1998?
Provide a short and direct response. 1.08. What is the ratio of the Employment to population ratio(%) in Estonia in 1992 to that in 1998?
Your answer should be very brief. 1.19. What is the ratio of the Employment to population ratio(%) in European Union in 1992 to that in 1999?
Make the answer very short. 0.97. What is the ratio of the Employment to population ratio(%) in Bosnia and Herzegovina in 1992 to that in 1999?
Give a very brief answer. 1.08. What is the ratio of the Employment to population ratio(%) in Estonia in 1992 to that in 1999?
Make the answer very short. 1.23. What is the ratio of the Employment to population ratio(%) in European Union in 1993 to that in 1994?
Provide a short and direct response. 1. What is the ratio of the Employment to population ratio(%) of Bosnia and Herzegovina in 1993 to that in 1994?
Your response must be concise. 1.04. What is the ratio of the Employment to population ratio(%) in Estonia in 1993 to that in 1994?
Give a very brief answer. 1.04. What is the ratio of the Employment to population ratio(%) in European Union in 1993 to that in 1995?
Your answer should be very brief. 1. What is the ratio of the Employment to population ratio(%) of Estonia in 1993 to that in 1995?
Make the answer very short. 1.11. What is the ratio of the Employment to population ratio(%) in Bosnia and Herzegovina in 1993 to that in 1996?
Give a very brief answer. 1.02. What is the ratio of the Employment to population ratio(%) of Equatorial Guinea in 1993 to that in 1996?
Make the answer very short. 0.99. What is the ratio of the Employment to population ratio(%) in Estonia in 1993 to that in 1996?
Your answer should be compact. 1.11. What is the ratio of the Employment to population ratio(%) in European Union in 1993 to that in 1997?
Offer a terse response. 0.98. What is the ratio of the Employment to population ratio(%) in Bosnia and Herzegovina in 1993 to that in 1997?
Your answer should be very brief. 1.07. What is the ratio of the Employment to population ratio(%) of Equatorial Guinea in 1993 to that in 1997?
Offer a very short reply. 0.97. What is the ratio of the Employment to population ratio(%) of Estonia in 1993 to that in 1997?
Offer a very short reply. 1.11. What is the ratio of the Employment to population ratio(%) of European Union in 1993 to that in 1998?
Your answer should be very brief. 0.97. What is the ratio of the Employment to population ratio(%) of Bosnia and Herzegovina in 1993 to that in 1998?
Your answer should be very brief. 1.06. What is the ratio of the Employment to population ratio(%) of Equatorial Guinea in 1993 to that in 1998?
Offer a very short reply. 1. What is the ratio of the Employment to population ratio(%) of Estonia in 1993 to that in 1998?
Provide a succinct answer. 1.12. What is the ratio of the Employment to population ratio(%) in European Union in 1993 to that in 1999?
Keep it short and to the point. 0.96. What is the ratio of the Employment to population ratio(%) in Bosnia and Herzegovina in 1993 to that in 1999?
Provide a short and direct response. 1.06. What is the ratio of the Employment to population ratio(%) in Estonia in 1993 to that in 1999?
Your answer should be compact. 1.16. What is the ratio of the Employment to population ratio(%) of European Union in 1994 to that in 1995?
Offer a terse response. 0.99. What is the ratio of the Employment to population ratio(%) of Bosnia and Herzegovina in 1994 to that in 1995?
Your response must be concise. 0.96. What is the ratio of the Employment to population ratio(%) in Equatorial Guinea in 1994 to that in 1995?
Offer a terse response. 1. What is the ratio of the Employment to population ratio(%) in Estonia in 1994 to that in 1995?
Provide a succinct answer. 1.06. What is the ratio of the Employment to population ratio(%) of European Union in 1994 to that in 1996?
Provide a short and direct response. 0.98. What is the ratio of the Employment to population ratio(%) in Bosnia and Herzegovina in 1994 to that in 1996?
Make the answer very short. 0.98. What is the ratio of the Employment to population ratio(%) in Equatorial Guinea in 1994 to that in 1996?
Your answer should be compact. 0.99. What is the ratio of the Employment to population ratio(%) in Estonia in 1994 to that in 1996?
Make the answer very short. 1.06. What is the ratio of the Employment to population ratio(%) in European Union in 1994 to that in 1997?
Give a very brief answer. 0.98. What is the ratio of the Employment to population ratio(%) in Bosnia and Herzegovina in 1994 to that in 1997?
Make the answer very short. 1.03. What is the ratio of the Employment to population ratio(%) of Equatorial Guinea in 1994 to that in 1997?
Keep it short and to the point. 0.98. What is the ratio of the Employment to population ratio(%) in Estonia in 1994 to that in 1997?
Your answer should be compact. 1.06. What is the ratio of the Employment to population ratio(%) in European Union in 1994 to that in 1998?
Offer a terse response. 0.97. What is the ratio of the Employment to population ratio(%) in Bosnia and Herzegovina in 1994 to that in 1998?
Your response must be concise. 1.02. What is the ratio of the Employment to population ratio(%) in Estonia in 1994 to that in 1998?
Give a very brief answer. 1.07. What is the ratio of the Employment to population ratio(%) in European Union in 1994 to that in 1999?
Make the answer very short. 0.96. What is the ratio of the Employment to population ratio(%) of Bosnia and Herzegovina in 1994 to that in 1999?
Your answer should be very brief. 1.02. What is the ratio of the Employment to population ratio(%) of European Union in 1995 to that in 1996?
Make the answer very short. 0.99. What is the ratio of the Employment to population ratio(%) of Bosnia and Herzegovina in 1995 to that in 1996?
Your answer should be compact. 1.02. What is the ratio of the Employment to population ratio(%) in Equatorial Guinea in 1995 to that in 1996?
Give a very brief answer. 0.99. What is the ratio of the Employment to population ratio(%) in European Union in 1995 to that in 1997?
Keep it short and to the point. 0.98. What is the ratio of the Employment to population ratio(%) in Bosnia and Herzegovina in 1995 to that in 1997?
Make the answer very short. 1.08. What is the ratio of the Employment to population ratio(%) of Equatorial Guinea in 1995 to that in 1997?
Your answer should be compact. 0.98. What is the ratio of the Employment to population ratio(%) in European Union in 1995 to that in 1998?
Ensure brevity in your answer.  0.97. What is the ratio of the Employment to population ratio(%) of Bosnia and Herzegovina in 1995 to that in 1998?
Your answer should be very brief. 1.07. What is the ratio of the Employment to population ratio(%) of Estonia in 1995 to that in 1998?
Ensure brevity in your answer.  1.01. What is the ratio of the Employment to population ratio(%) in European Union in 1995 to that in 1999?
Give a very brief answer. 0.96. What is the ratio of the Employment to population ratio(%) of Bosnia and Herzegovina in 1995 to that in 1999?
Provide a succinct answer. 1.07. What is the ratio of the Employment to population ratio(%) in Estonia in 1995 to that in 1999?
Provide a succinct answer. 1.05. What is the ratio of the Employment to population ratio(%) in Bosnia and Herzegovina in 1996 to that in 1997?
Your answer should be very brief. 1.06. What is the ratio of the Employment to population ratio(%) of Equatorial Guinea in 1996 to that in 1997?
Provide a succinct answer. 0.99. What is the ratio of the Employment to population ratio(%) of European Union in 1996 to that in 1998?
Provide a succinct answer. 0.98. What is the ratio of the Employment to population ratio(%) of Bosnia and Herzegovina in 1996 to that in 1998?
Ensure brevity in your answer.  1.05. What is the ratio of the Employment to population ratio(%) in Equatorial Guinea in 1996 to that in 1998?
Keep it short and to the point. 1.01. What is the ratio of the Employment to population ratio(%) in Estonia in 1996 to that in 1998?
Your answer should be compact. 1.01. What is the ratio of the Employment to population ratio(%) in European Union in 1996 to that in 1999?
Your answer should be compact. 0.97. What is the ratio of the Employment to population ratio(%) in Bosnia and Herzegovina in 1996 to that in 1999?
Make the answer very short. 1.05. What is the ratio of the Employment to population ratio(%) of Equatorial Guinea in 1996 to that in 1999?
Give a very brief answer. 1.01. What is the ratio of the Employment to population ratio(%) of Estonia in 1996 to that in 1999?
Give a very brief answer. 1.05. What is the ratio of the Employment to population ratio(%) of Bosnia and Herzegovina in 1997 to that in 1998?
Keep it short and to the point. 0.99. What is the ratio of the Employment to population ratio(%) in Equatorial Guinea in 1997 to that in 1998?
Make the answer very short. 1.03. What is the ratio of the Employment to population ratio(%) of Estonia in 1997 to that in 1998?
Your response must be concise. 1.01. What is the ratio of the Employment to population ratio(%) in European Union in 1997 to that in 1999?
Make the answer very short. 0.98. What is the ratio of the Employment to population ratio(%) in Bosnia and Herzegovina in 1997 to that in 1999?
Make the answer very short. 0.99. What is the ratio of the Employment to population ratio(%) of Equatorial Guinea in 1997 to that in 1999?
Make the answer very short. 1.03. What is the ratio of the Employment to population ratio(%) in Estonia in 1997 to that in 1999?
Offer a terse response. 1.05. What is the ratio of the Employment to population ratio(%) in European Union in 1998 to that in 1999?
Offer a terse response. 0.99. What is the ratio of the Employment to population ratio(%) in Equatorial Guinea in 1998 to that in 1999?
Offer a terse response. 1. What is the ratio of the Employment to population ratio(%) in Estonia in 1998 to that in 1999?
Provide a succinct answer. 1.03. What is the difference between the highest and the second highest Employment to population ratio(%) in European Union?
Provide a succinct answer. 0.55. What is the difference between the highest and the second highest Employment to population ratio(%) in Equatorial Guinea?
Give a very brief answer. 1.1. What is the difference between the highest and the second highest Employment to population ratio(%) in Estonia?
Your answer should be compact. 3.3. What is the difference between the highest and the lowest Employment to population ratio(%) in European Union?
Make the answer very short. 1.89. What is the difference between the highest and the lowest Employment to population ratio(%) in Equatorial Guinea?
Provide a succinct answer. 2.1. What is the difference between the highest and the lowest Employment to population ratio(%) in Estonia?
Make the answer very short. 10.8. 